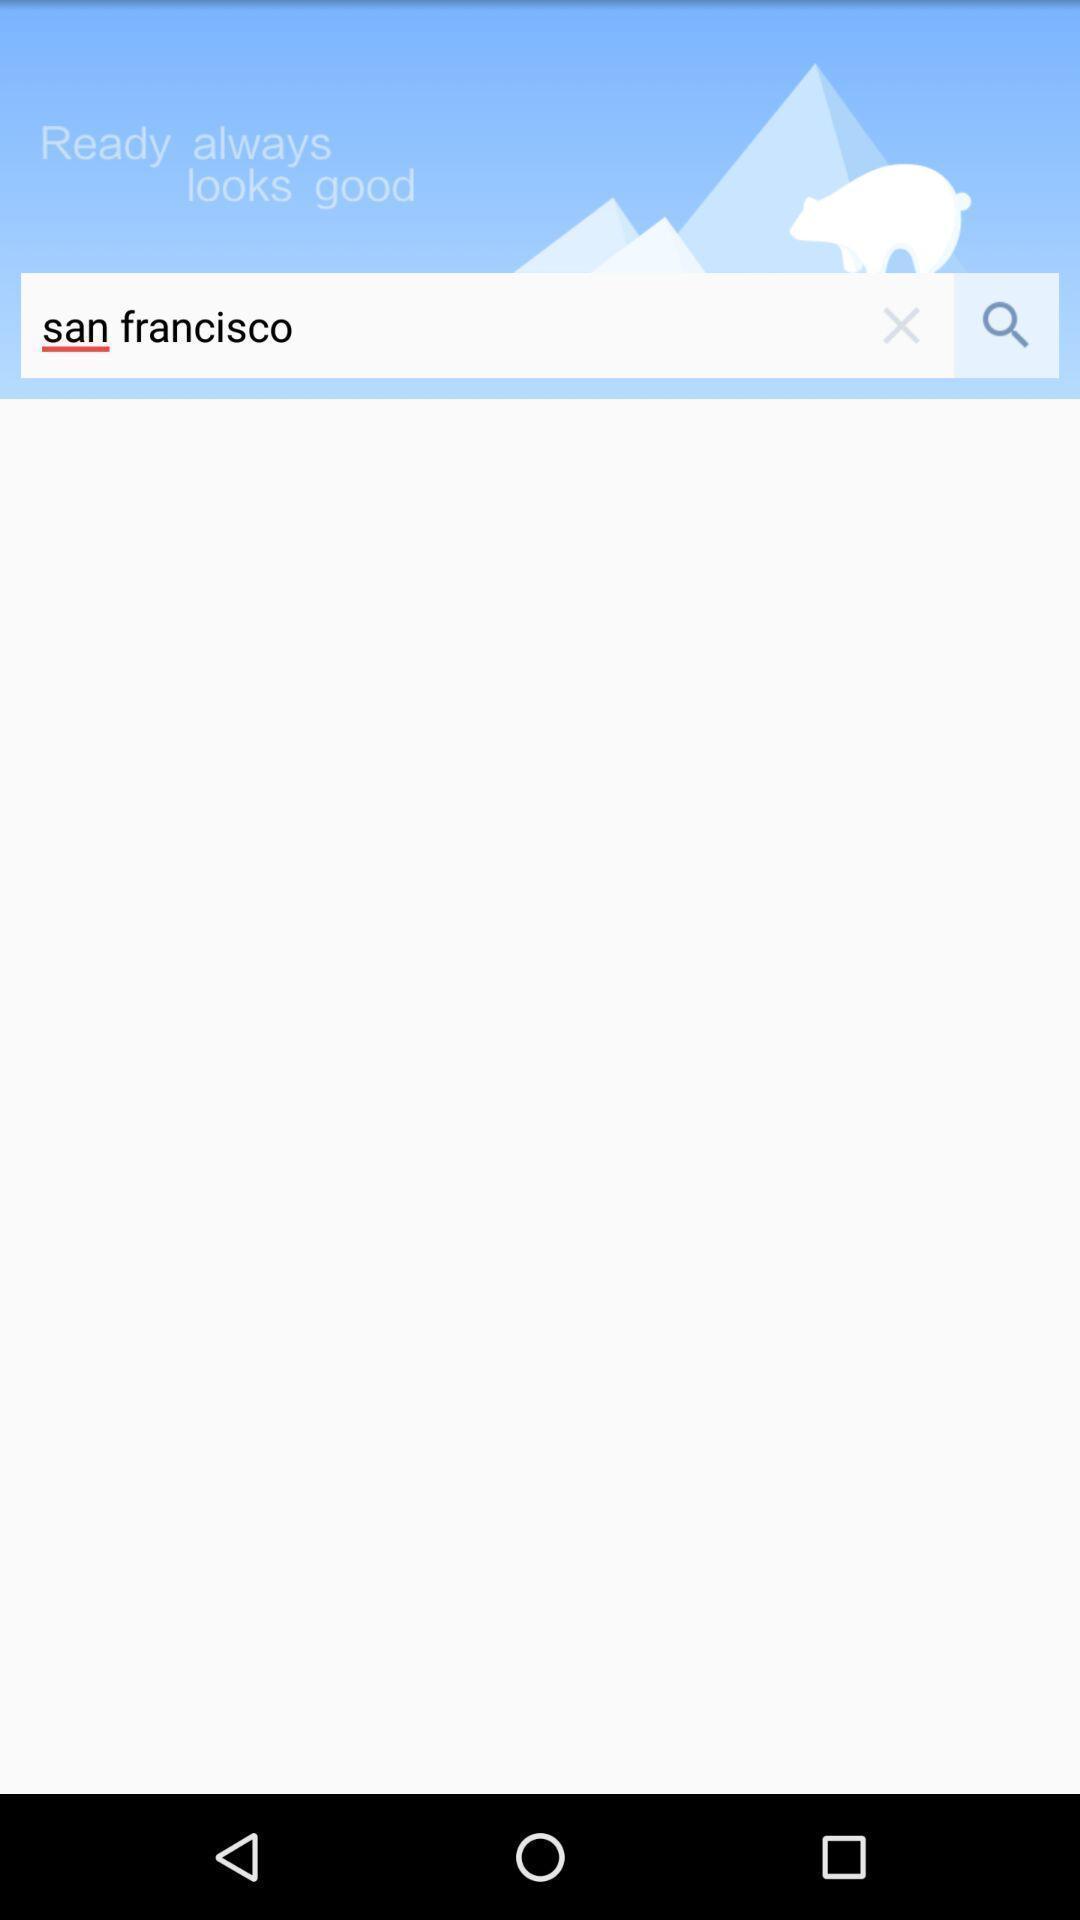Provide a textual representation of this image. Search page of san francisco. 